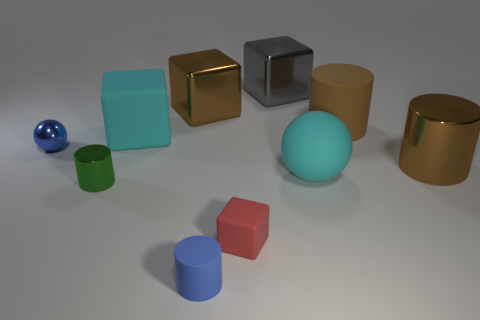Subtract all blocks. How many objects are left? 6 Subtract 0 cyan cylinders. How many objects are left? 10 Subtract all big rubber balls. Subtract all blue metal things. How many objects are left? 8 Add 1 blue cylinders. How many blue cylinders are left? 2 Add 1 large blue things. How many large blue things exist? 1 